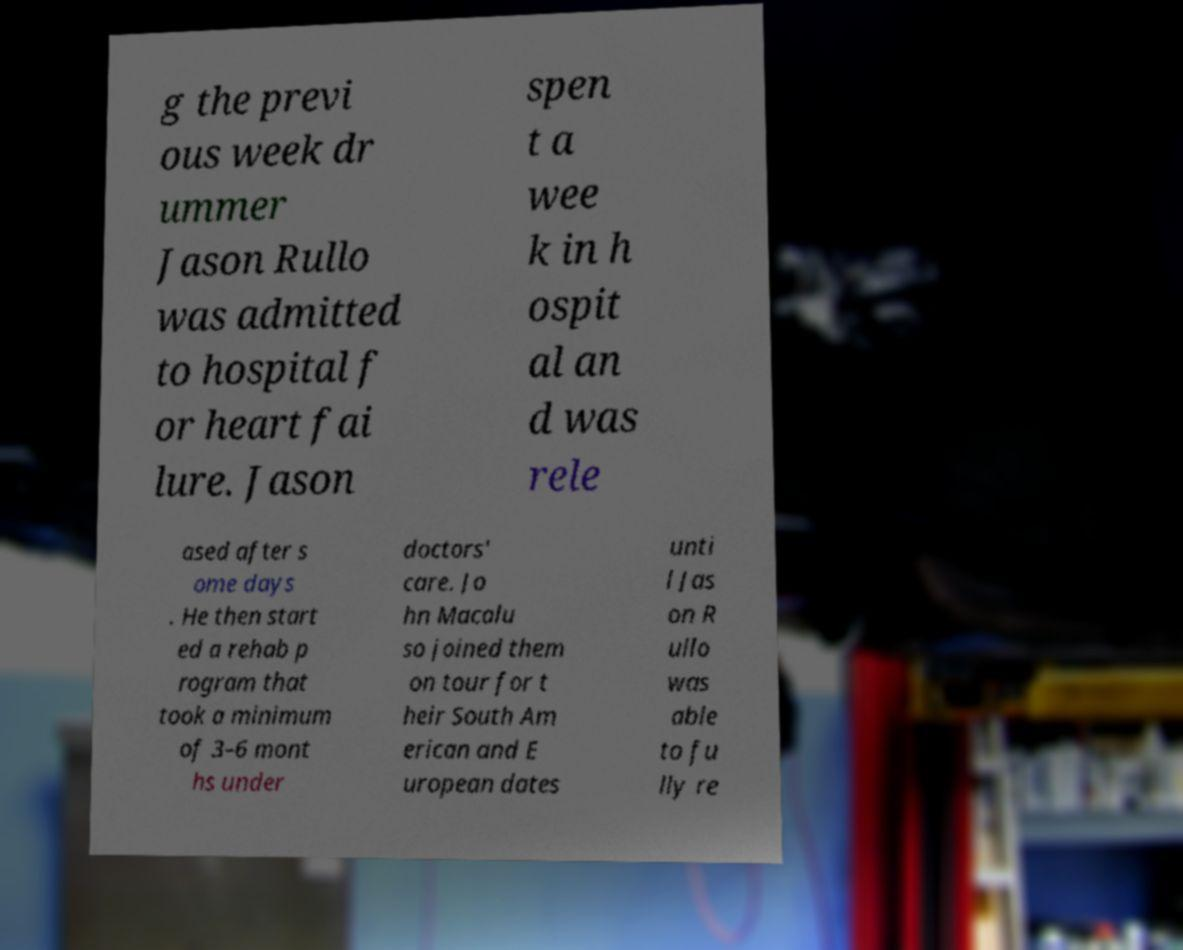For documentation purposes, I need the text within this image transcribed. Could you provide that? g the previ ous week dr ummer Jason Rullo was admitted to hospital f or heart fai lure. Jason spen t a wee k in h ospit al an d was rele ased after s ome days . He then start ed a rehab p rogram that took a minimum of 3–6 mont hs under doctors' care. Jo hn Macalu so joined them on tour for t heir South Am erican and E uropean dates unti l Jas on R ullo was able to fu lly re 